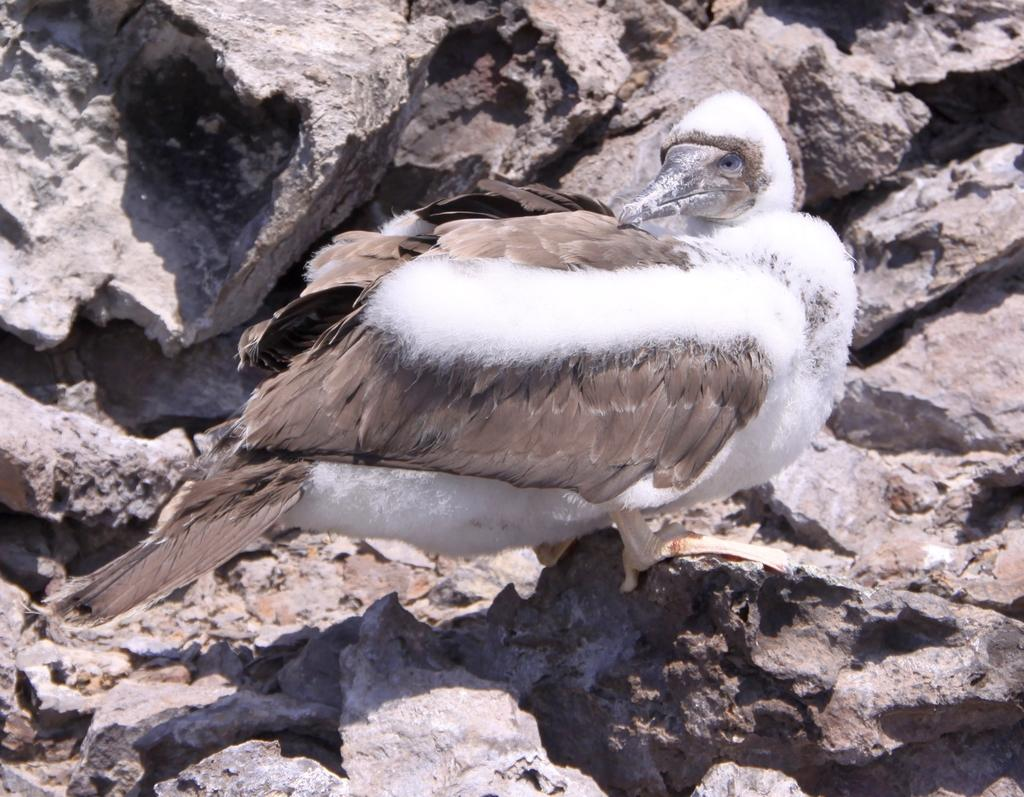What type of animal is in the image? There is a white color bird in the image. Where is the bird located? The bird is on stones. What color are the bird's feathers? The bird's feathers are in brown color. What type of plant is the manager holding in the image? There is no manager or plant present in the image; it features a white color bird on stones with brown feathers. 